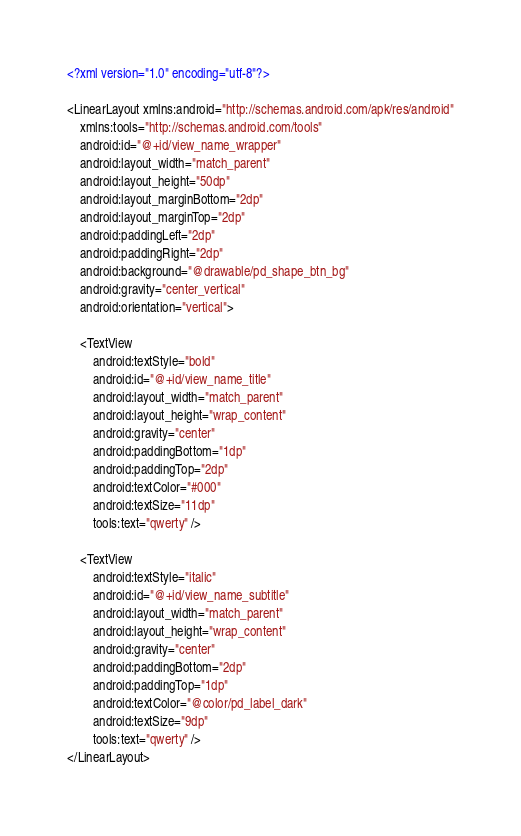<code> <loc_0><loc_0><loc_500><loc_500><_XML_><?xml version="1.0" encoding="utf-8"?>

<LinearLayout xmlns:android="http://schemas.android.com/apk/res/android"
    xmlns:tools="http://schemas.android.com/tools"
    android:id="@+id/view_name_wrapper"
    android:layout_width="match_parent"
    android:layout_height="50dp"
    android:layout_marginBottom="2dp"
    android:layout_marginTop="2dp"
    android:paddingLeft="2dp"
    android:paddingRight="2dp"
    android:background="@drawable/pd_shape_btn_bg"
    android:gravity="center_vertical"
    android:orientation="vertical">

    <TextView
        android:textStyle="bold"
        android:id="@+id/view_name_title"
        android:layout_width="match_parent"
        android:layout_height="wrap_content"
        android:gravity="center"
        android:paddingBottom="1dp"
        android:paddingTop="2dp"
        android:textColor="#000"
        android:textSize="11dp"
        tools:text="qwerty" />

    <TextView
        android:textStyle="italic"
        android:id="@+id/view_name_subtitle"
        android:layout_width="match_parent"
        android:layout_height="wrap_content"
        android:gravity="center"
        android:paddingBottom="2dp"
        android:paddingTop="1dp"
        android:textColor="@color/pd_label_dark"
        android:textSize="9dp"
        tools:text="qwerty" />
</LinearLayout>

</code> 